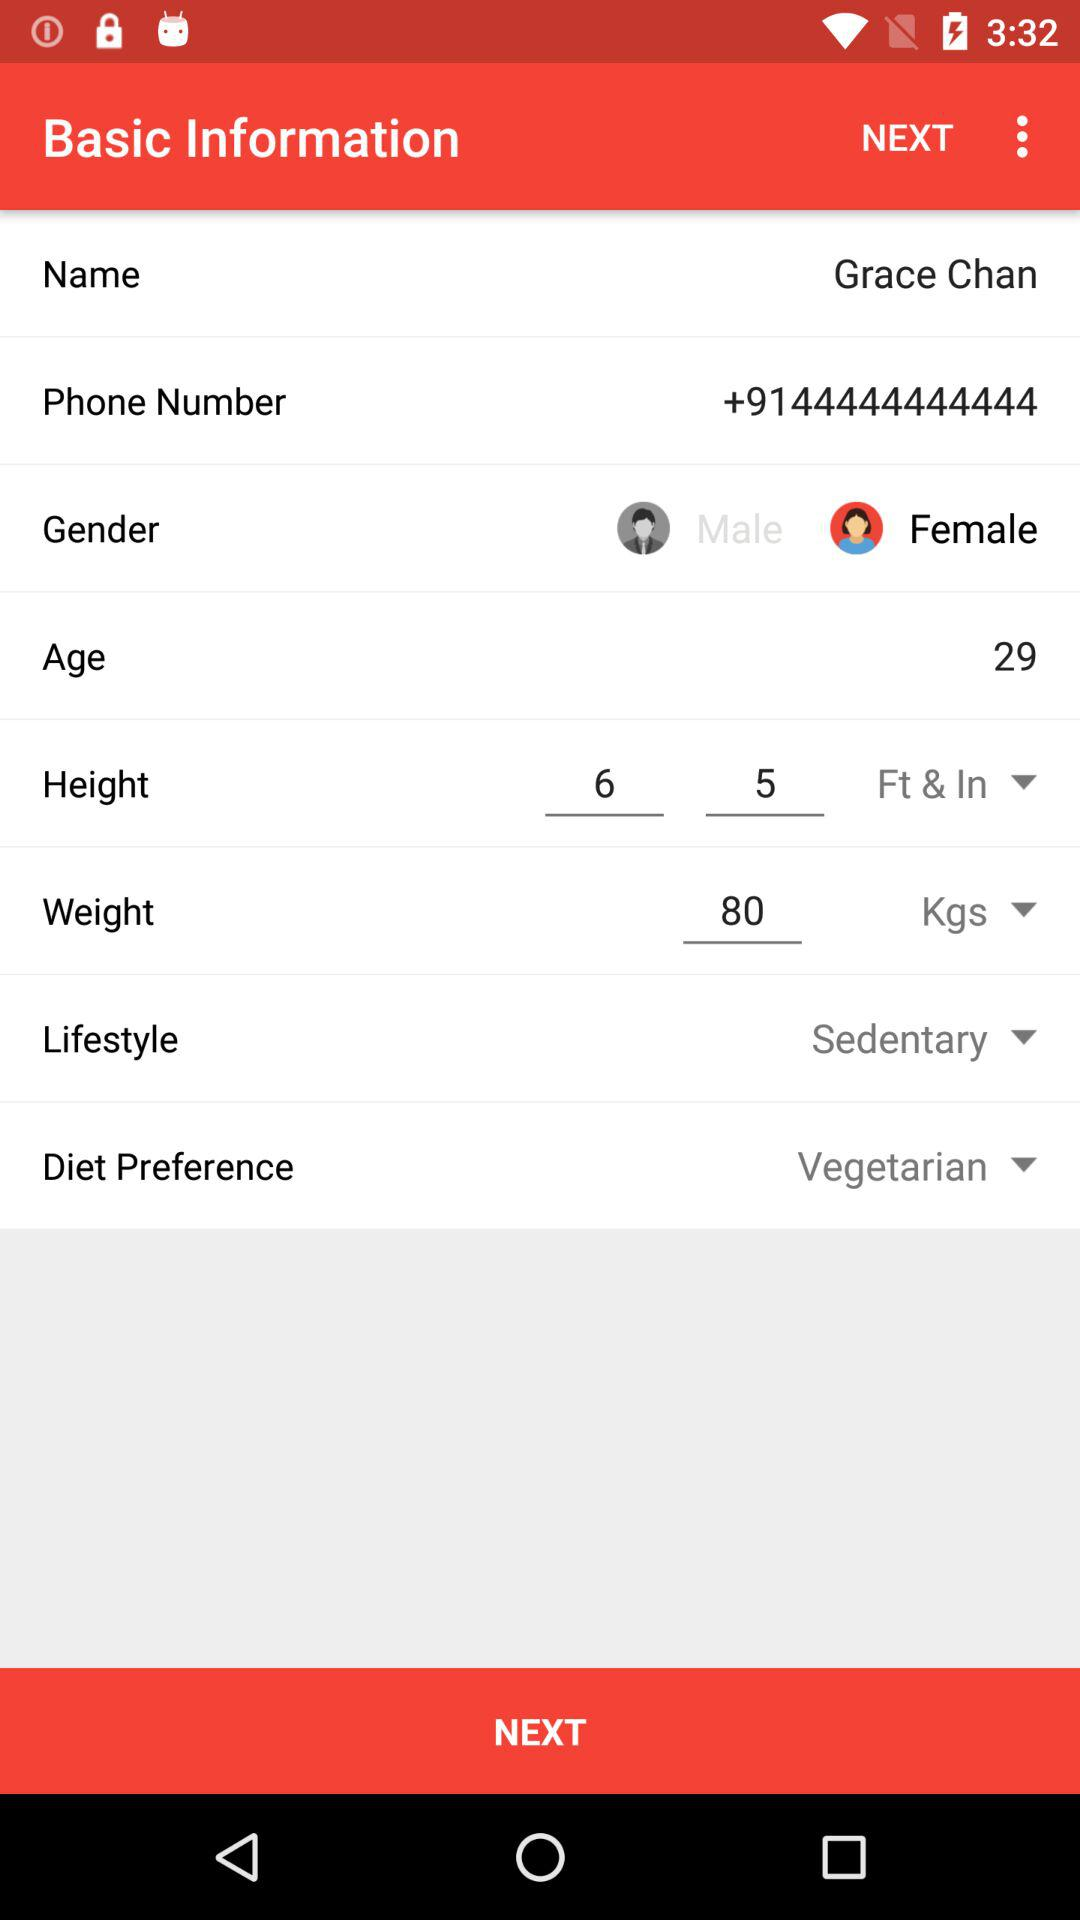How many kilograms does Grace Chan weigh? Grace Chan weighs 80 kilograms. 